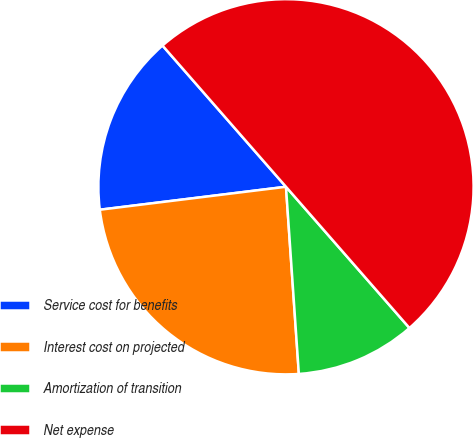Convert chart to OTSL. <chart><loc_0><loc_0><loc_500><loc_500><pie_chart><fcel>Service cost for benefits<fcel>Interest cost on projected<fcel>Amortization of transition<fcel>Net expense<nl><fcel>15.52%<fcel>24.14%<fcel>10.34%<fcel>50.0%<nl></chart> 